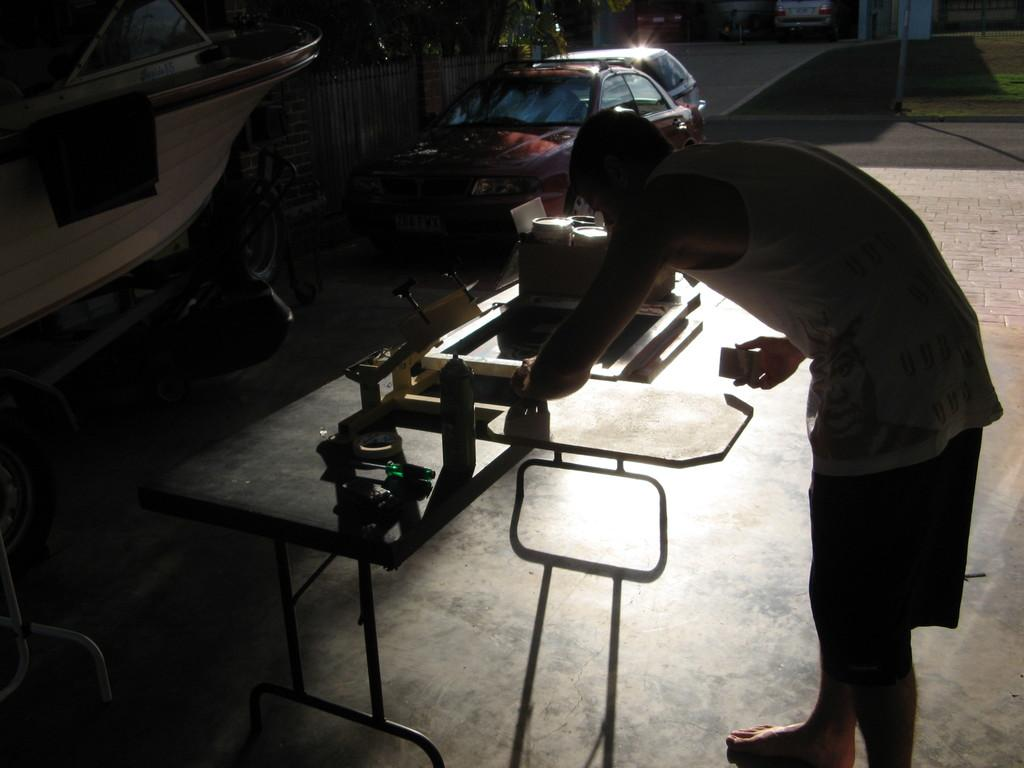What is the man in the image doing? The man is standing in front of a table. What can be seen on the table? There are things on the table. What type of vehicle is present in the image? There is a vehicle in the image. What architectural feature can be seen in the image? There is a fence in the image. What type of natural elements are visible in the image? There are trees in the image. Where is the library located in the image? There is no library present in the image. What type of wood can be seen in the image? There is no wood visible in the image. 